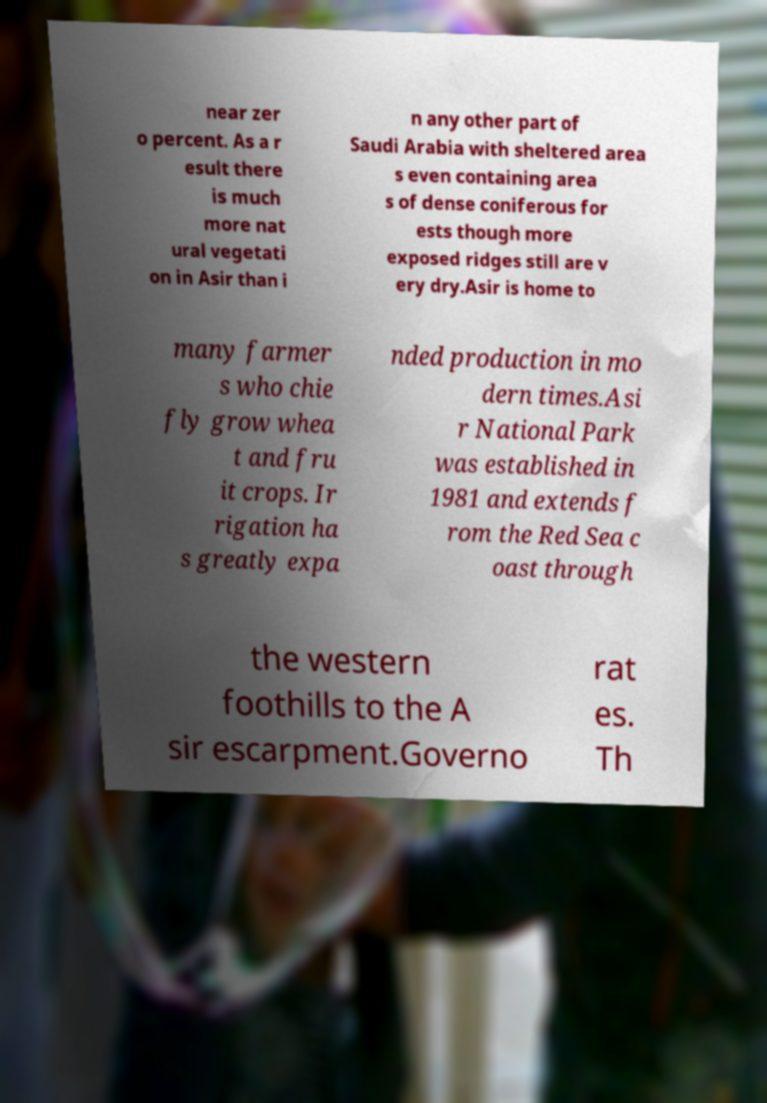For documentation purposes, I need the text within this image transcribed. Could you provide that? near zer o percent. As a r esult there is much more nat ural vegetati on in Asir than i n any other part of Saudi Arabia with sheltered area s even containing area s of dense coniferous for ests though more exposed ridges still are v ery dry.Asir is home to many farmer s who chie fly grow whea t and fru it crops. Ir rigation ha s greatly expa nded production in mo dern times.Asi r National Park was established in 1981 and extends f rom the Red Sea c oast through the western foothills to the A sir escarpment.Governo rat es. Th 